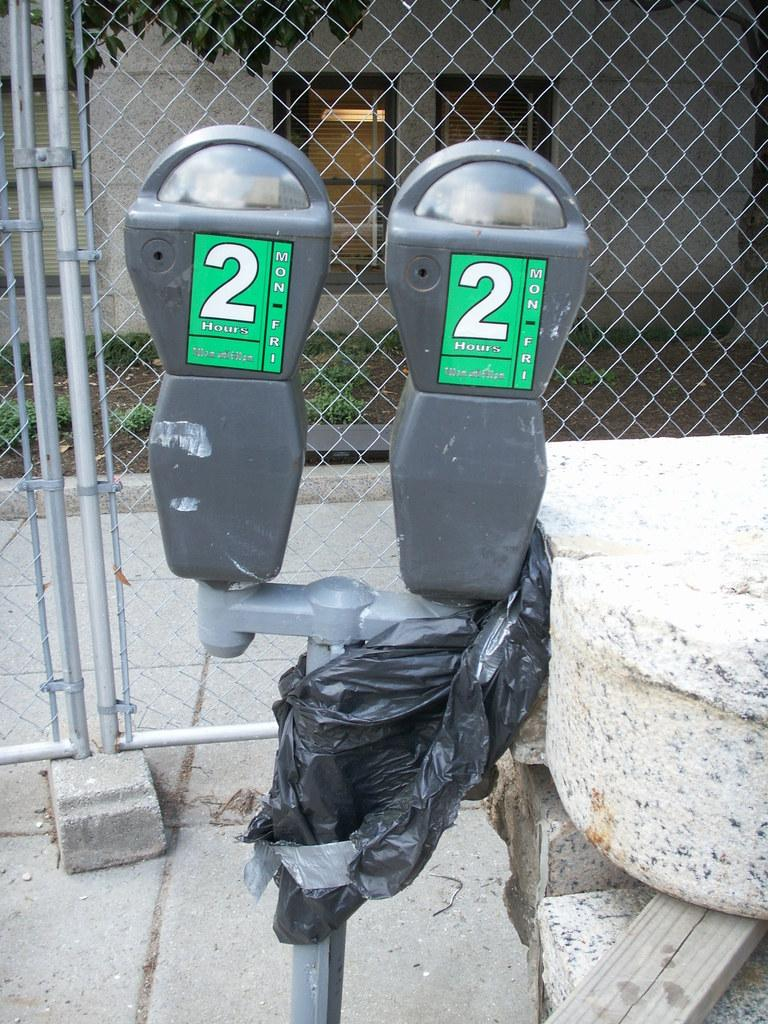Provide a one-sentence caption for the provided image. a set of two parking meters that have 2 hours and Mon to Fri on them. 